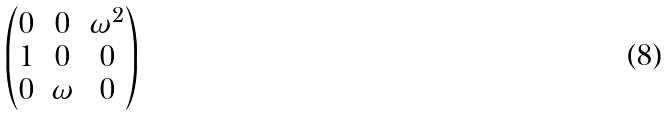Convert formula to latex. <formula><loc_0><loc_0><loc_500><loc_500>\begin{pmatrix} 0 & 0 & \omega ^ { 2 } \\ 1 & 0 & 0 \\ 0 & \omega & 0 \end{pmatrix}</formula> 